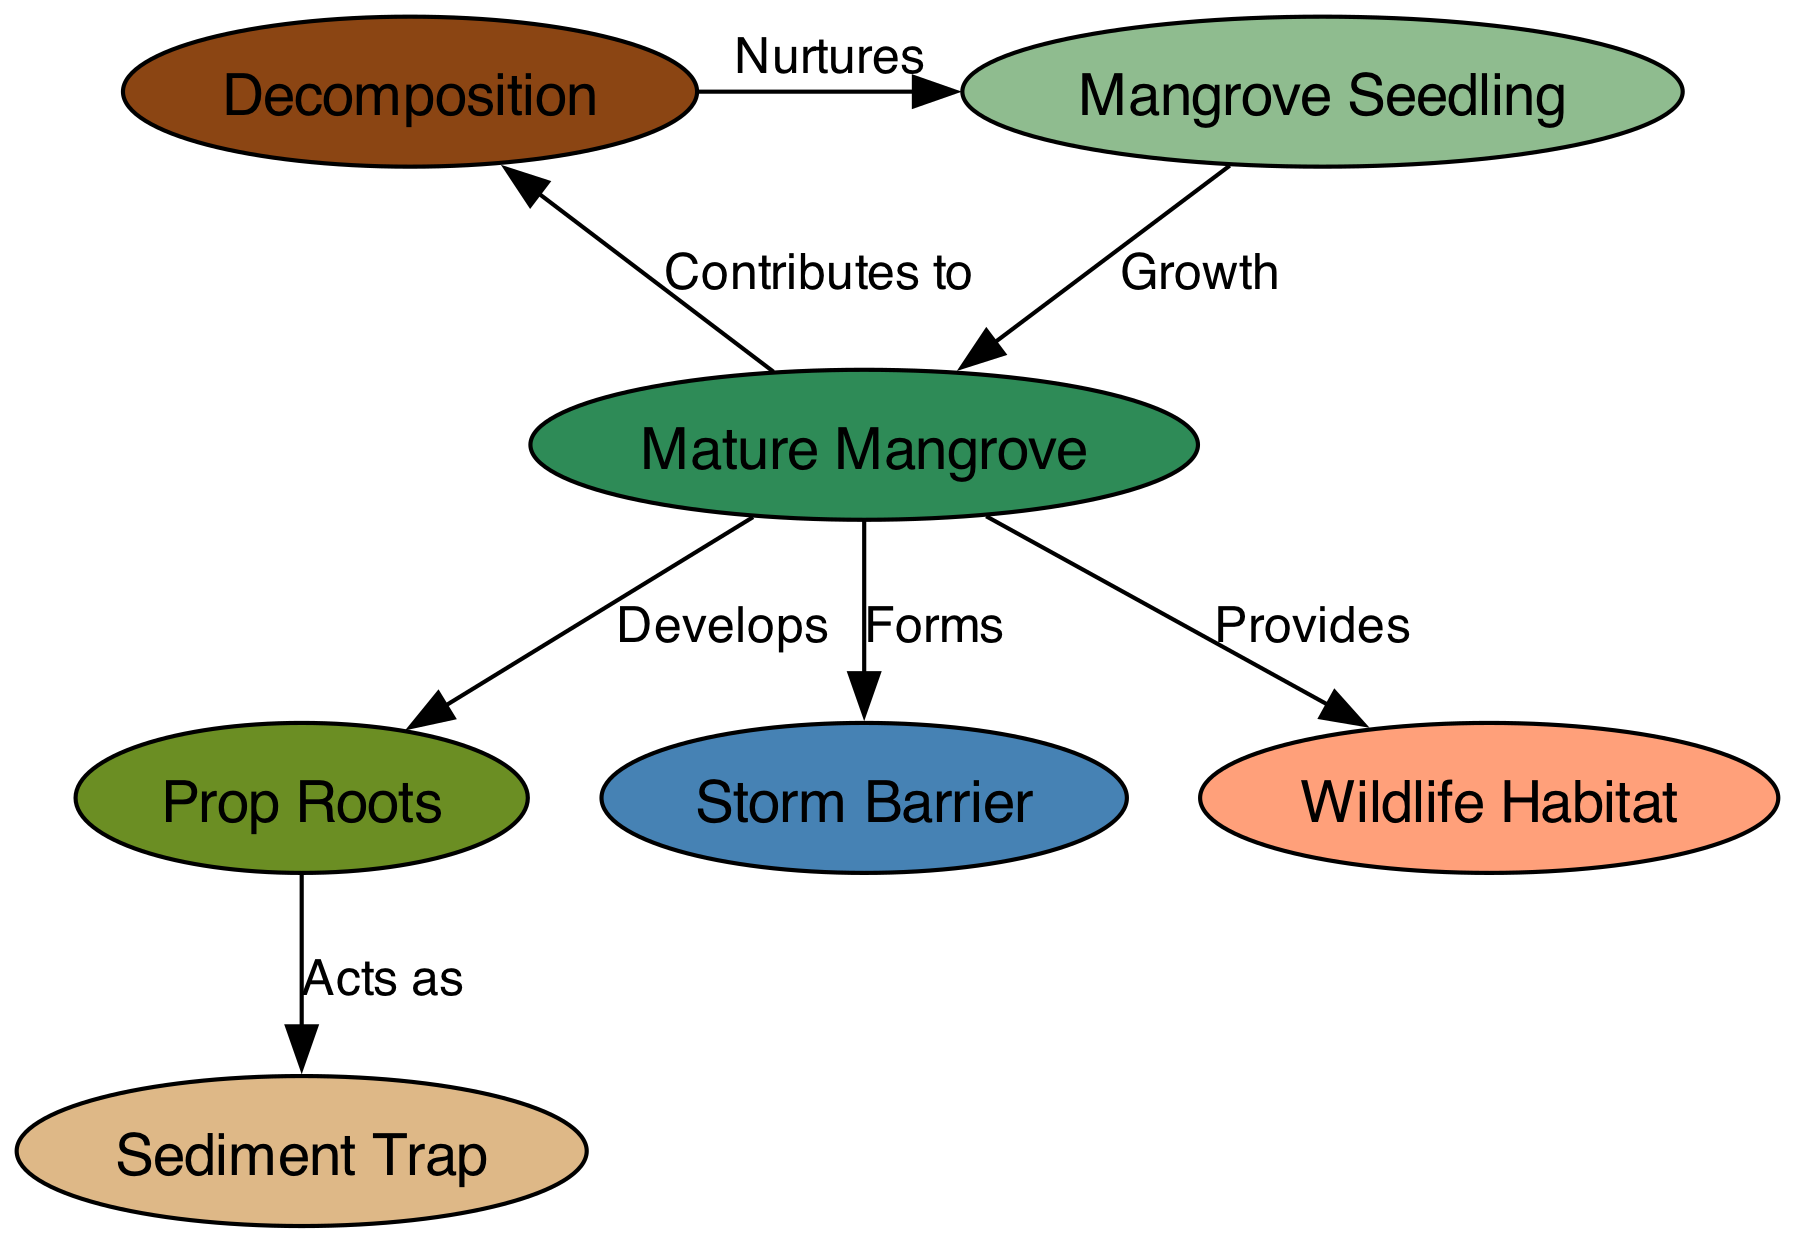What is the first stage of the mangrove life cycle? The diagram starts with the node that is labeled "Mangrove Seedling" as the first stage, indicating the beginning of the life cycle.
Answer: Mangrove Seedling How many nodes are displayed in the diagram? By counting all the unique nodes represented in the diagram, there are a total of 7 nodes visible.
Answer: 7 What does a mature mangrove develop? The diagram shows an edge labeled "Develops" leading from the "Mature Mangrove" to the "Prop Roots," indicating the development of prop roots.
Answer: Prop Roots What function do prop roots serve in the ecosystem? According to the diagram, prop roots act as a "Sediment Trap," meaning they play the role of trapping sediments in the coastal environment.
Answer: Sediment Trap What do mature mangroves provide for wildlife? The edge labeled "Provides" indicates that mature mangroves give a "Wildlife Habitat," serving as a crucial living space for various wildlife species.
Answer: Wildlife Habitat How does decomposition contribute to the mangrove life cycle? The diagram states that decomposition has an edge labeled "Nurtures" pointing to "Mangrove Seedling," indicating that decomposition helps nurture new seedlings.
Answer: Nurtures What ecological feature do mature mangroves form? The relationship labeled "Forms" in the diagram shows that mature mangroves create a "Storm Barrier," underlining their importance in coastal protection.
Answer: Storm Barrier What role does decomposition play in the ecosystem? The diagram illustrates that decomposition contributes to "Mangrove Seedling," suggesting that it is an essential process that supports the growth of new seedlings.
Answer: Contributes to Mangrove Seedling What connects decomposition back to the life cycle? Following the arrows in the diagram, "Decomposition" directly connects back to "Mangrove Seedling" through the labeled relationship "Nurtures," completing the cycle.
Answer: Nurtures 